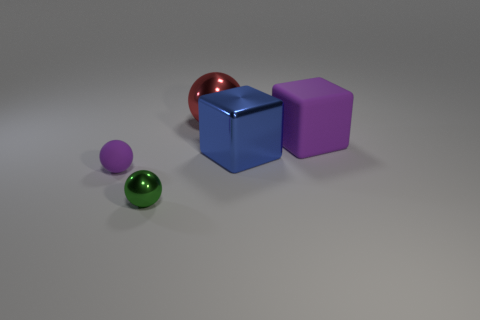There is a matte object that is left of the large purple thing; is there a tiny green metal ball that is to the left of it?
Your answer should be compact. No. What number of large metal cubes are right of the big metallic cube?
Offer a very short reply. 0. The other tiny thing that is the same shape as the small purple object is what color?
Provide a succinct answer. Green. Are the big thing that is in front of the purple block and the purple object to the right of the tiny purple thing made of the same material?
Offer a terse response. No. There is a tiny metal ball; is it the same color as the matte object to the left of the green thing?
Offer a very short reply. No. The object that is behind the big blue object and to the left of the purple cube has what shape?
Offer a terse response. Sphere. What number of small blue matte blocks are there?
Make the answer very short. 0. There is another matte thing that is the same color as the small rubber object; what shape is it?
Offer a terse response. Cube. What size is the other shiny object that is the same shape as the large purple thing?
Offer a terse response. Large. Is the shape of the purple thing that is right of the small green sphere the same as  the large blue thing?
Your answer should be compact. Yes. 